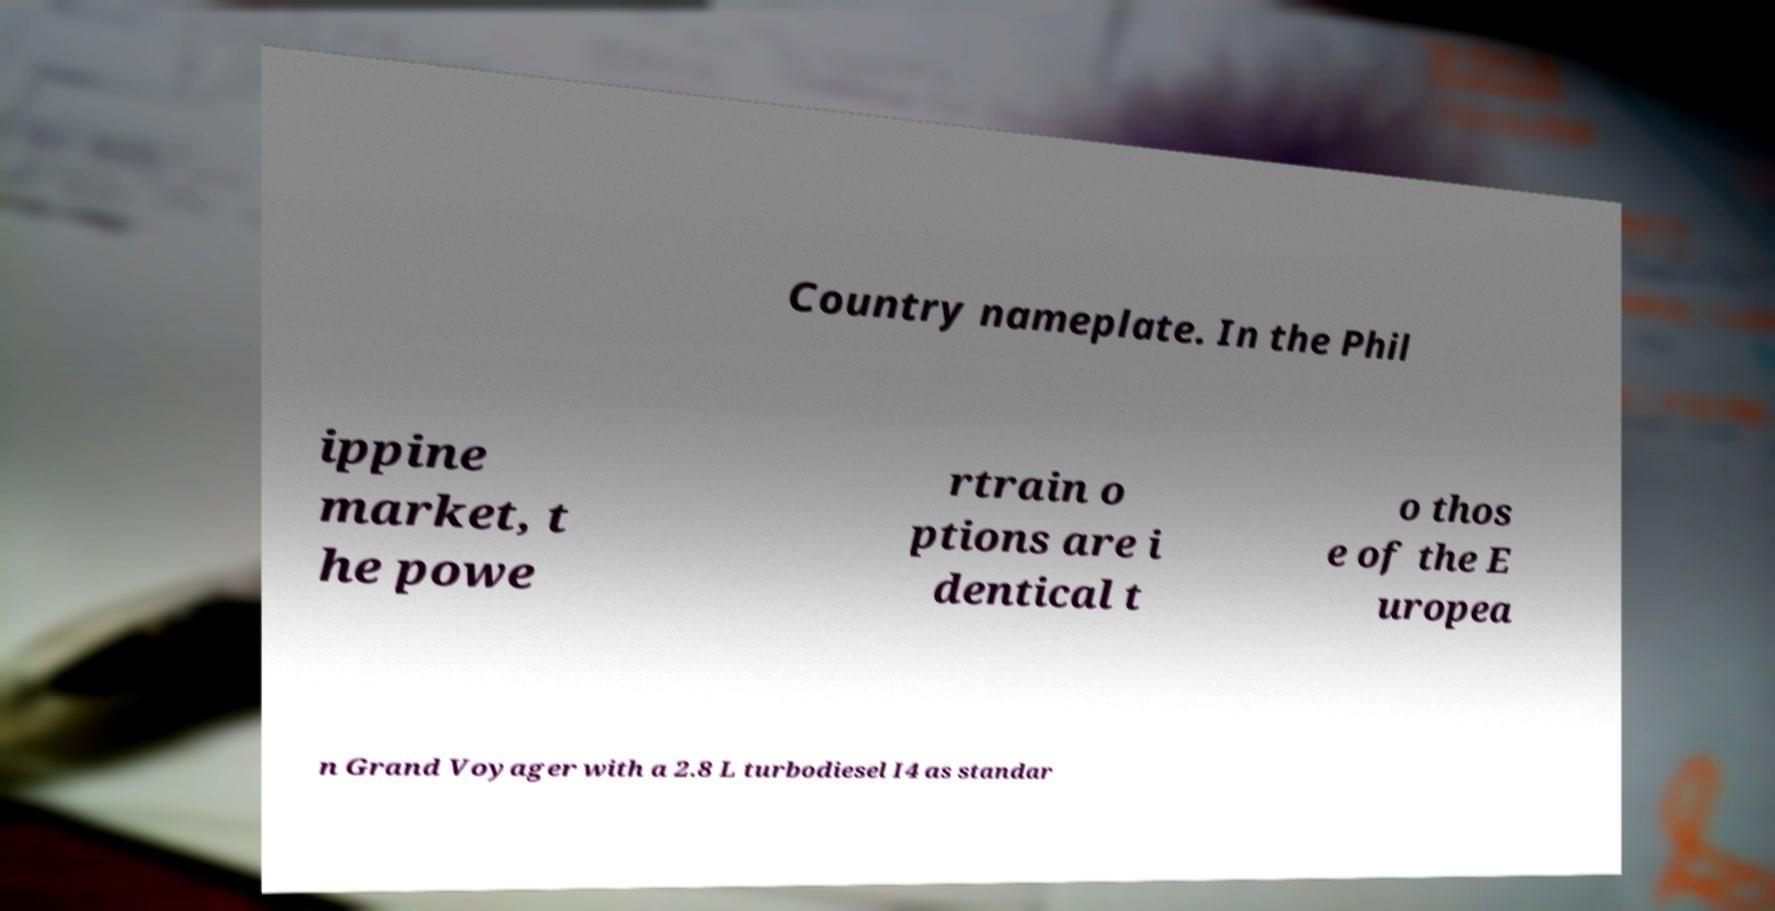Can you accurately transcribe the text from the provided image for me? Country nameplate. In the Phil ippine market, t he powe rtrain o ptions are i dentical t o thos e of the E uropea n Grand Voyager with a 2.8 L turbodiesel I4 as standar 